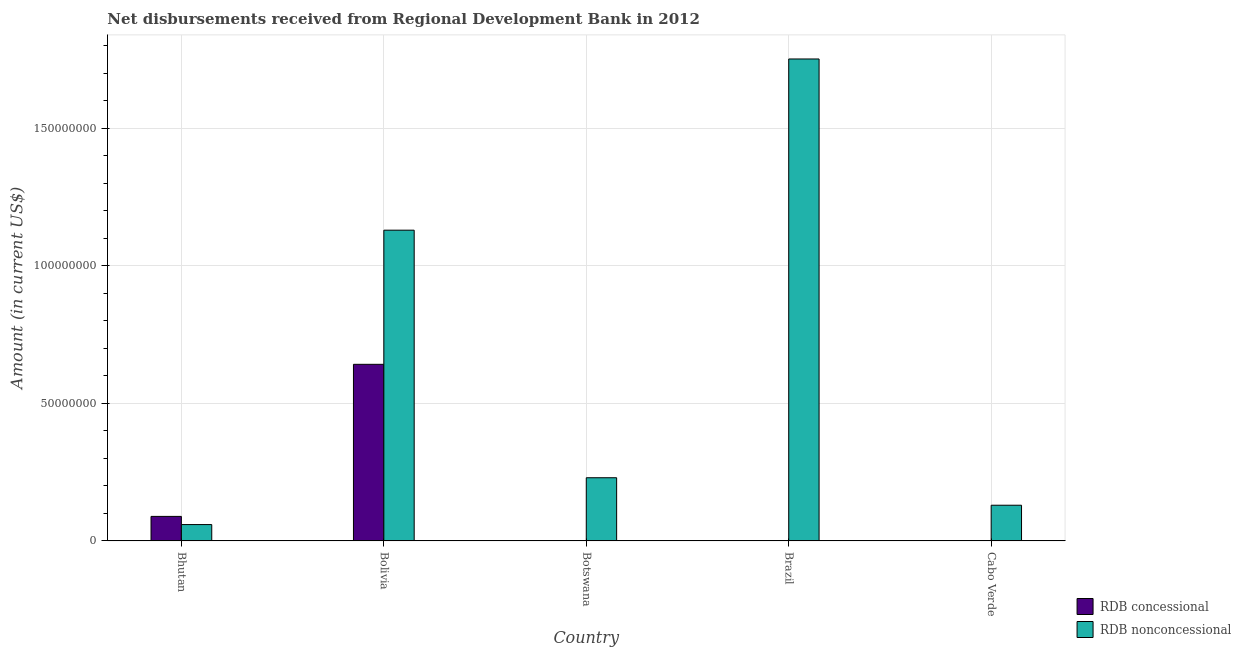Are the number of bars on each tick of the X-axis equal?
Your answer should be very brief. No. What is the label of the 3rd group of bars from the left?
Your answer should be very brief. Botswana. In how many cases, is the number of bars for a given country not equal to the number of legend labels?
Your response must be concise. 3. What is the net non concessional disbursements from rdb in Brazil?
Offer a terse response. 1.75e+08. Across all countries, what is the maximum net non concessional disbursements from rdb?
Provide a succinct answer. 1.75e+08. Across all countries, what is the minimum net non concessional disbursements from rdb?
Keep it short and to the point. 5.95e+06. What is the total net non concessional disbursements from rdb in the graph?
Your answer should be compact. 3.30e+08. What is the difference between the net non concessional disbursements from rdb in Brazil and that in Cabo Verde?
Your answer should be compact. 1.62e+08. What is the difference between the net non concessional disbursements from rdb in Bolivia and the net concessional disbursements from rdb in Cabo Verde?
Your answer should be very brief. 1.13e+08. What is the average net non concessional disbursements from rdb per country?
Provide a succinct answer. 6.60e+07. What is the difference between the net non concessional disbursements from rdb and net concessional disbursements from rdb in Bhutan?
Provide a succinct answer. -2.97e+06. What is the ratio of the net non concessional disbursements from rdb in Bhutan to that in Botswana?
Provide a short and direct response. 0.26. What is the difference between the highest and the second highest net non concessional disbursements from rdb?
Offer a very short reply. 6.22e+07. What is the difference between the highest and the lowest net non concessional disbursements from rdb?
Offer a very short reply. 1.69e+08. Is the sum of the net non concessional disbursements from rdb in Bolivia and Cabo Verde greater than the maximum net concessional disbursements from rdb across all countries?
Provide a succinct answer. Yes. How many countries are there in the graph?
Provide a succinct answer. 5. Does the graph contain any zero values?
Keep it short and to the point. Yes. What is the title of the graph?
Your answer should be very brief. Net disbursements received from Regional Development Bank in 2012. Does "% of GNI" appear as one of the legend labels in the graph?
Your answer should be very brief. No. What is the label or title of the X-axis?
Ensure brevity in your answer.  Country. What is the Amount (in current US$) of RDB concessional in Bhutan?
Your answer should be very brief. 8.92e+06. What is the Amount (in current US$) in RDB nonconcessional in Bhutan?
Make the answer very short. 5.95e+06. What is the Amount (in current US$) in RDB concessional in Bolivia?
Ensure brevity in your answer.  6.42e+07. What is the Amount (in current US$) of RDB nonconcessional in Bolivia?
Provide a succinct answer. 1.13e+08. What is the Amount (in current US$) in RDB concessional in Botswana?
Offer a terse response. 0. What is the Amount (in current US$) in RDB nonconcessional in Botswana?
Make the answer very short. 2.30e+07. What is the Amount (in current US$) in RDB concessional in Brazil?
Provide a short and direct response. 0. What is the Amount (in current US$) of RDB nonconcessional in Brazil?
Make the answer very short. 1.75e+08. What is the Amount (in current US$) in RDB concessional in Cabo Verde?
Keep it short and to the point. 0. What is the Amount (in current US$) in RDB nonconcessional in Cabo Verde?
Provide a short and direct response. 1.30e+07. Across all countries, what is the maximum Amount (in current US$) in RDB concessional?
Offer a terse response. 6.42e+07. Across all countries, what is the maximum Amount (in current US$) in RDB nonconcessional?
Make the answer very short. 1.75e+08. Across all countries, what is the minimum Amount (in current US$) in RDB concessional?
Offer a very short reply. 0. Across all countries, what is the minimum Amount (in current US$) of RDB nonconcessional?
Ensure brevity in your answer.  5.95e+06. What is the total Amount (in current US$) of RDB concessional in the graph?
Give a very brief answer. 7.31e+07. What is the total Amount (in current US$) of RDB nonconcessional in the graph?
Provide a short and direct response. 3.30e+08. What is the difference between the Amount (in current US$) of RDB concessional in Bhutan and that in Bolivia?
Your answer should be compact. -5.53e+07. What is the difference between the Amount (in current US$) in RDB nonconcessional in Bhutan and that in Bolivia?
Your answer should be very brief. -1.07e+08. What is the difference between the Amount (in current US$) of RDB nonconcessional in Bhutan and that in Botswana?
Give a very brief answer. -1.70e+07. What is the difference between the Amount (in current US$) in RDB nonconcessional in Bhutan and that in Brazil?
Ensure brevity in your answer.  -1.69e+08. What is the difference between the Amount (in current US$) of RDB nonconcessional in Bhutan and that in Cabo Verde?
Keep it short and to the point. -7.03e+06. What is the difference between the Amount (in current US$) in RDB nonconcessional in Bolivia and that in Botswana?
Your answer should be compact. 9.00e+07. What is the difference between the Amount (in current US$) in RDB nonconcessional in Bolivia and that in Brazil?
Provide a short and direct response. -6.22e+07. What is the difference between the Amount (in current US$) in RDB nonconcessional in Bolivia and that in Cabo Verde?
Provide a short and direct response. 1.00e+08. What is the difference between the Amount (in current US$) in RDB nonconcessional in Botswana and that in Brazil?
Ensure brevity in your answer.  -1.52e+08. What is the difference between the Amount (in current US$) of RDB nonconcessional in Botswana and that in Cabo Verde?
Keep it short and to the point. 9.99e+06. What is the difference between the Amount (in current US$) in RDB nonconcessional in Brazil and that in Cabo Verde?
Give a very brief answer. 1.62e+08. What is the difference between the Amount (in current US$) of RDB concessional in Bhutan and the Amount (in current US$) of RDB nonconcessional in Bolivia?
Offer a very short reply. -1.04e+08. What is the difference between the Amount (in current US$) of RDB concessional in Bhutan and the Amount (in current US$) of RDB nonconcessional in Botswana?
Offer a very short reply. -1.41e+07. What is the difference between the Amount (in current US$) of RDB concessional in Bhutan and the Amount (in current US$) of RDB nonconcessional in Brazil?
Your answer should be very brief. -1.66e+08. What is the difference between the Amount (in current US$) in RDB concessional in Bhutan and the Amount (in current US$) in RDB nonconcessional in Cabo Verde?
Your answer should be very brief. -4.06e+06. What is the difference between the Amount (in current US$) of RDB concessional in Bolivia and the Amount (in current US$) of RDB nonconcessional in Botswana?
Give a very brief answer. 4.12e+07. What is the difference between the Amount (in current US$) in RDB concessional in Bolivia and the Amount (in current US$) in RDB nonconcessional in Brazil?
Provide a short and direct response. -1.11e+08. What is the difference between the Amount (in current US$) in RDB concessional in Bolivia and the Amount (in current US$) in RDB nonconcessional in Cabo Verde?
Ensure brevity in your answer.  5.12e+07. What is the average Amount (in current US$) in RDB concessional per country?
Your answer should be compact. 1.46e+07. What is the average Amount (in current US$) in RDB nonconcessional per country?
Keep it short and to the point. 6.60e+07. What is the difference between the Amount (in current US$) in RDB concessional and Amount (in current US$) in RDB nonconcessional in Bhutan?
Provide a succinct answer. 2.97e+06. What is the difference between the Amount (in current US$) of RDB concessional and Amount (in current US$) of RDB nonconcessional in Bolivia?
Make the answer very short. -4.88e+07. What is the ratio of the Amount (in current US$) in RDB concessional in Bhutan to that in Bolivia?
Provide a short and direct response. 0.14. What is the ratio of the Amount (in current US$) of RDB nonconcessional in Bhutan to that in Bolivia?
Your answer should be compact. 0.05. What is the ratio of the Amount (in current US$) in RDB nonconcessional in Bhutan to that in Botswana?
Your answer should be very brief. 0.26. What is the ratio of the Amount (in current US$) in RDB nonconcessional in Bhutan to that in Brazil?
Provide a succinct answer. 0.03. What is the ratio of the Amount (in current US$) of RDB nonconcessional in Bhutan to that in Cabo Verde?
Your answer should be very brief. 0.46. What is the ratio of the Amount (in current US$) of RDB nonconcessional in Bolivia to that in Botswana?
Keep it short and to the point. 4.92. What is the ratio of the Amount (in current US$) of RDB nonconcessional in Bolivia to that in Brazil?
Your answer should be compact. 0.64. What is the ratio of the Amount (in current US$) in RDB nonconcessional in Bolivia to that in Cabo Verde?
Your response must be concise. 8.7. What is the ratio of the Amount (in current US$) of RDB nonconcessional in Botswana to that in Brazil?
Give a very brief answer. 0.13. What is the ratio of the Amount (in current US$) in RDB nonconcessional in Botswana to that in Cabo Verde?
Provide a short and direct response. 1.77. What is the ratio of the Amount (in current US$) of RDB nonconcessional in Brazil to that in Cabo Verde?
Your answer should be very brief. 13.5. What is the difference between the highest and the second highest Amount (in current US$) of RDB nonconcessional?
Your answer should be very brief. 6.22e+07. What is the difference between the highest and the lowest Amount (in current US$) in RDB concessional?
Offer a terse response. 6.42e+07. What is the difference between the highest and the lowest Amount (in current US$) in RDB nonconcessional?
Provide a short and direct response. 1.69e+08. 